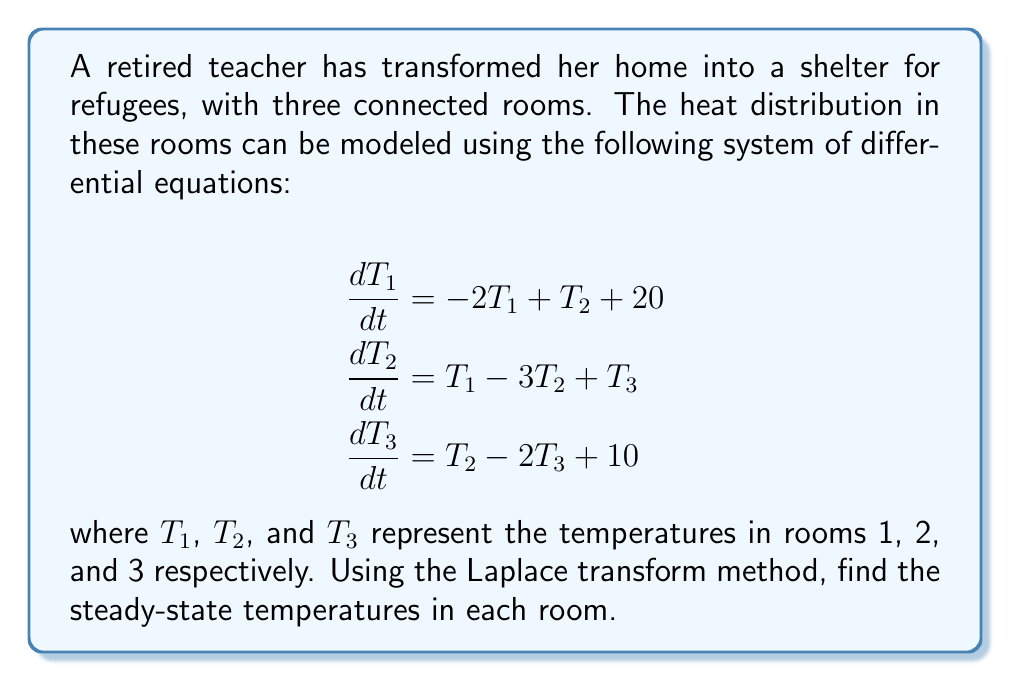Teach me how to tackle this problem. To solve this problem using Laplace transforms, we'll follow these steps:

1) Take the Laplace transform of each equation:

$$\begin{align}
s\mathcal{L}\{T_1\} - T_1(0) &= -2\mathcal{L}\{T_1\} + \mathcal{L}\{T_2\} + \frac{20}{s} \\
s\mathcal{L}\{T_2\} - T_2(0) &= \mathcal{L}\{T_1\} - 3\mathcal{L}\{T_2\} + \mathcal{L}\{T_3\} \\
s\mathcal{L}\{T_3\} - T_3(0) &= \mathcal{L}\{T_2\} - 2\mathcal{L}\{T_3\} + \frac{10}{s}
\end{align}$$

2) For steady-state solutions, we're interested in the final value theorem:

$$\lim_{t \to \infty} f(t) = \lim_{s \to 0} s F(s)$$

3) As $s \to 0$, the initial conditions become irrelevant. Let $\mathcal{L}\{T_1\} = X$, $\mathcal{L}\{T_2\} = Y$, and $\mathcal{L}\{T_3\} = Z$. Our system becomes:

$$\begin{align}
0 &= -2X + Y + \frac{20}{s} \\
0 &= X - 3Y + Z \\
0 &= Y - 2Z + \frac{10}{s}
\end{align}$$

4) Multiply each equation by $s$:

$$\begin{align}
0 &= -2sX + sY + 20 \\
0 &= sX - 3sY + sZ \\
0 &= sY - 2sZ + 10
\end{align}$$

5) As $s \to 0$, $sX$, $sY$, and $sZ$ approach the steady-state values of $T_1$, $T_2$, and $T_3$ respectively. Let's call these $T_1^*$, $T_2^*$, and $T_3^*$. Our system becomes:

$$\begin{align}
0 &= -2T_1^* + T_2^* + 20 \\
0 &= T_1^* - 3T_2^* + T_3^* \\
0 &= T_2^* - 2T_3^* + 10
\end{align}$$

6) Solve this system of linear equations:

From the third equation: $T_2^* = 2T_3^* - 10$
Substitute into the second equation:
$T_1^* - 3(2T_3^* - 10) + T_3^* = 0$
$T_1^* - 6T_3^* + 30 + T_3^* = 0$
$T_1^* = 5T_3^* - 30$

Substitute both into the first equation:
$0 = -2(5T_3^* - 30) + (2T_3^* - 10) + 20$
$0 = -10T_3^* + 60 + 2T_3^* - 10 + 20$
$0 = -8T_3^* + 70$
$T_3^* = 8.75$

Backsubstitute to find $T_2^*$ and $T_1^*$:
$T_2^* = 2(8.75) - 10 = 7.5$
$T_1^* = 5(8.75) - 30 = 13.75$
Answer: The steady-state temperatures are:
Room 1: $T_1^* = 13.75°C$
Room 2: $T_2^* = 7.5°C$
Room 3: $T_3^* = 8.75°C$ 